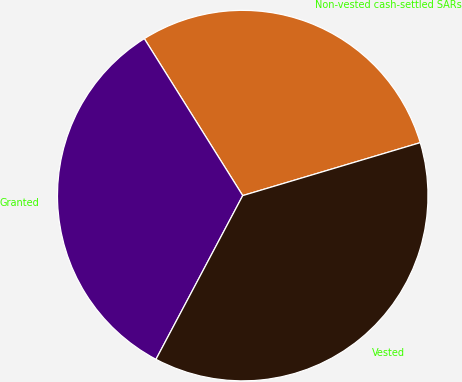Convert chart to OTSL. <chart><loc_0><loc_0><loc_500><loc_500><pie_chart><fcel>Non-vested cash-settled SARs<fcel>Granted<fcel>Vested<nl><fcel>29.3%<fcel>33.33%<fcel>37.37%<nl></chart> 